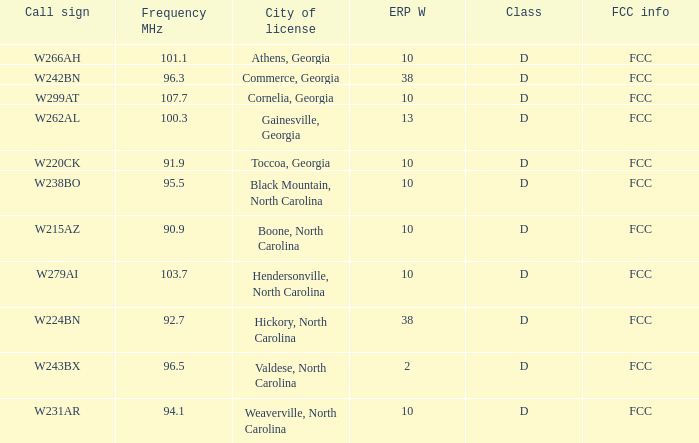Write the full table. {'header': ['Call sign', 'Frequency MHz', 'City of license', 'ERP W', 'Class', 'FCC info'], 'rows': [['W266AH', '101.1', 'Athens, Georgia', '10', 'D', 'FCC'], ['W242BN', '96.3', 'Commerce, Georgia', '38', 'D', 'FCC'], ['W299AT', '107.7', 'Cornelia, Georgia', '10', 'D', 'FCC'], ['W262AL', '100.3', 'Gainesville, Georgia', '13', 'D', 'FCC'], ['W220CK', '91.9', 'Toccoa, Georgia', '10', 'D', 'FCC'], ['W238BO', '95.5', 'Black Mountain, North Carolina', '10', 'D', 'FCC'], ['W215AZ', '90.9', 'Boone, North Carolina', '10', 'D', 'FCC'], ['W279AI', '103.7', 'Hendersonville, North Carolina', '10', 'D', 'FCC'], ['W224BN', '92.7', 'Hickory, North Carolina', '38', 'D', 'FCC'], ['W243BX', '96.5', 'Valdese, North Carolina', '2', 'D', 'FCC'], ['W231AR', '94.1', 'Weaverville, North Carolina', '10', 'D', 'FCC']]} What class is the city of black mountain, north carolina? D. 